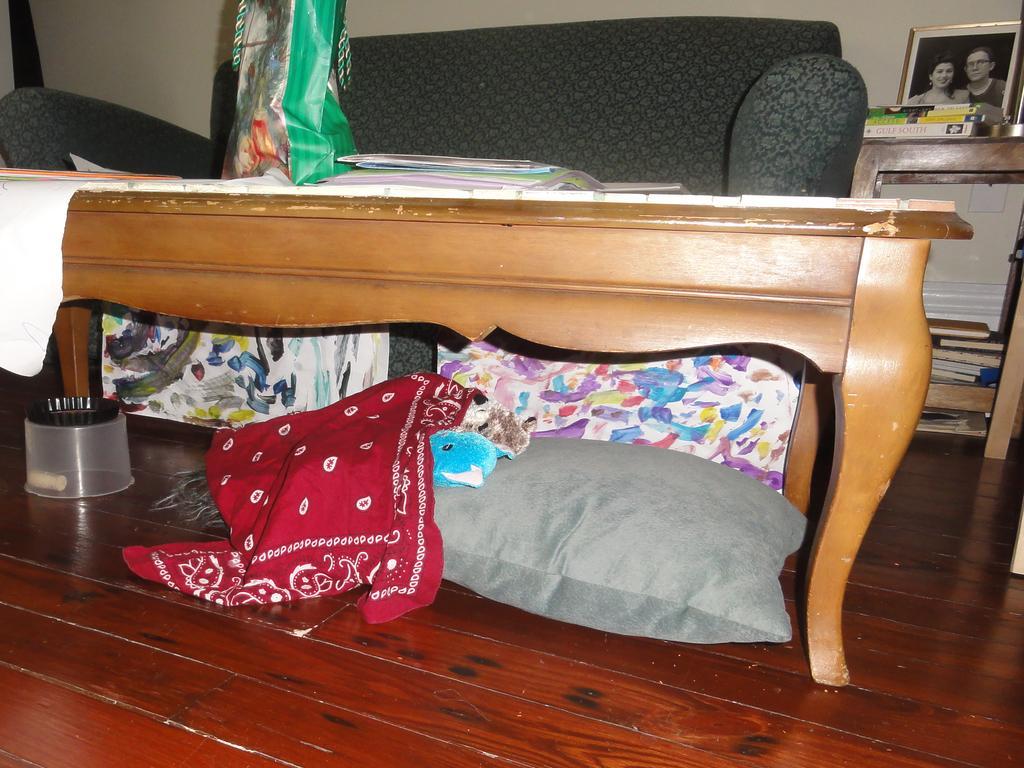Please provide a concise description of this image. In this picture i can see a sofa and a table with some papers and a bag on it and I can see a photo frame and few books on another table and few books under the table and I can see pillows and a box under the another table. 